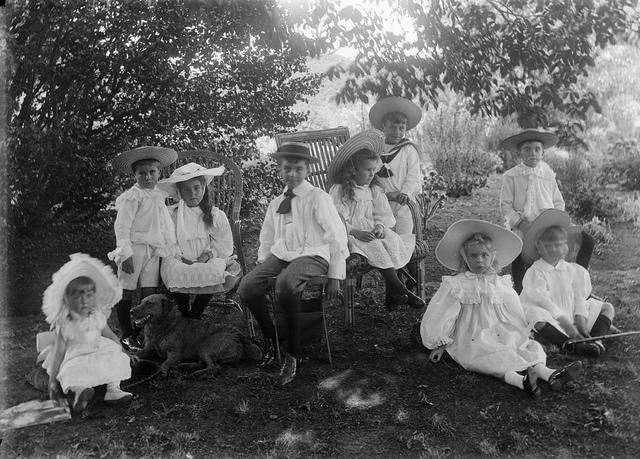Are all of the people wearing hats?
Concise answer only. Yes. Is this a typical modern day family?
Concise answer only. No. Is this a family picture?
Quick response, please. Yes. 